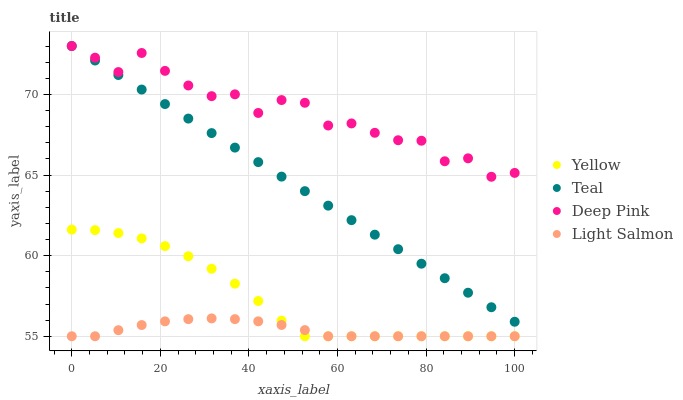Does Light Salmon have the minimum area under the curve?
Answer yes or no. Yes. Does Deep Pink have the maximum area under the curve?
Answer yes or no. Yes. Does Teal have the minimum area under the curve?
Answer yes or no. No. Does Teal have the maximum area under the curve?
Answer yes or no. No. Is Teal the smoothest?
Answer yes or no. Yes. Is Deep Pink the roughest?
Answer yes or no. Yes. Is Deep Pink the smoothest?
Answer yes or no. No. Is Teal the roughest?
Answer yes or no. No. Does Light Salmon have the lowest value?
Answer yes or no. Yes. Does Teal have the lowest value?
Answer yes or no. No. Does Teal have the highest value?
Answer yes or no. Yes. Does Yellow have the highest value?
Answer yes or no. No. Is Yellow less than Teal?
Answer yes or no. Yes. Is Teal greater than Light Salmon?
Answer yes or no. Yes. Does Yellow intersect Light Salmon?
Answer yes or no. Yes. Is Yellow less than Light Salmon?
Answer yes or no. No. Is Yellow greater than Light Salmon?
Answer yes or no. No. Does Yellow intersect Teal?
Answer yes or no. No. 